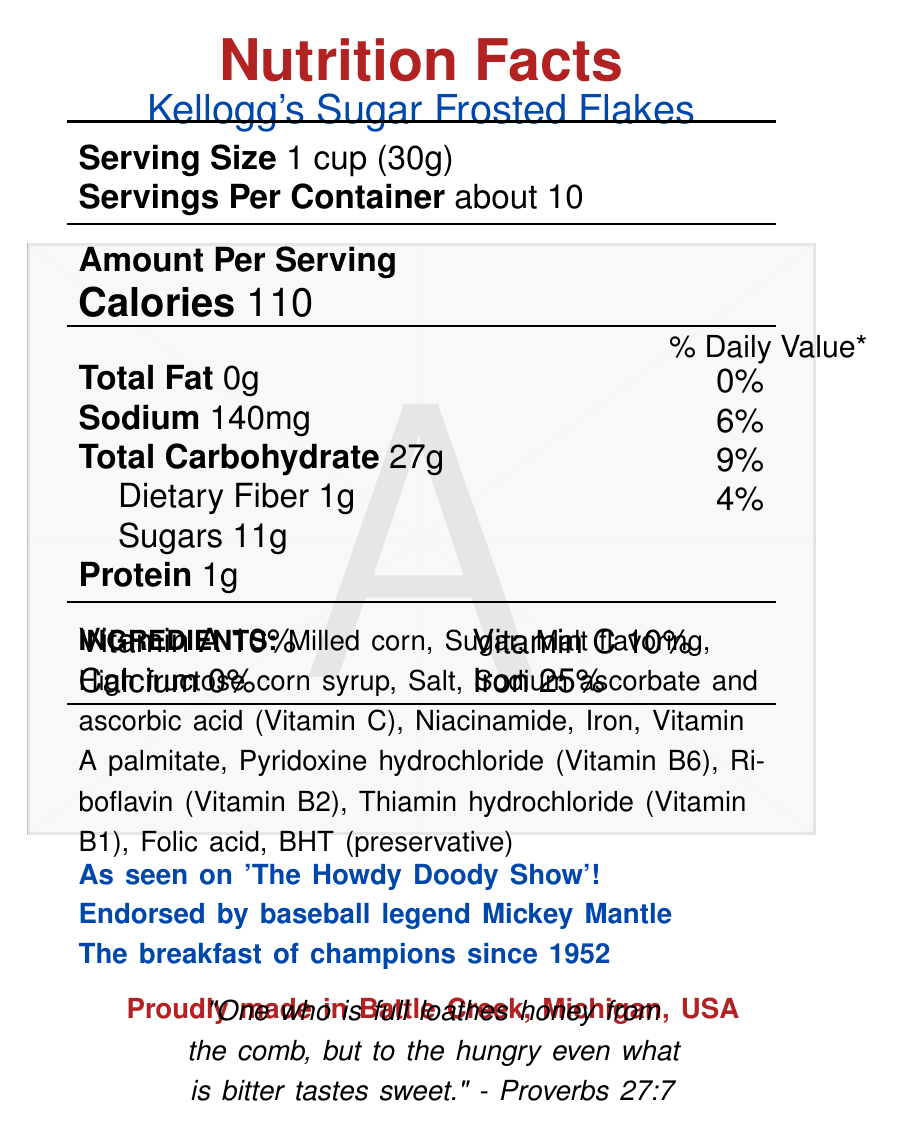What is the serving size for Kellogg's Sugar Frosted Flakes? The serving size is explicitly mentioned as 1 cup (30g) in the document.
Answer: 1 cup (30g) How many servings are there per container of Kellogg's Sugar Frosted Flakes? The document states there are about 10 servings per container.
Answer: About 10 How many calories are there per serving? The document clearly lists the calorie content per serving as 110.
Answer: 110 What is the % Daily Value for sodium in a serving? The % Daily Value for sodium is listed as 6% for a serving size.
Answer: 6% What are the ingredients in Kellogg's Sugar Frosted Flakes? The ingredients are listed in the document under the "INGREDIENTS" section.
Answer: Milled corn, Sugar, Malt flavoring, High fructose corn syrup, Salt, Sodium ascorbate and ascorbic acid (Vitamin C), Niacinamide, Iron, Vitamin A palmitate, Pyridoxine hydrochloride (Vitamin B6), Riboflavin (Vitamin B2), Thiamin hydrochloride (Vitamin B1), Folic acid, BHT (preservative) What vitamins and minerals are found in Kellogg's Sugar Frosted Flakes? A. Vitamin D, Vitamin B12, Zinc B. Vitamin A, Vitamin C, Iron C. Calcium, Magnesium, Potassium The document specifies that the cereal contains Vitamin A (10%), Vitamin C (10%), and Iron (25%).
Answer: B Which of the following statements is true about Kellogg's Sugar Frosted Flakes? A. It contains 2g of protein per serving B. It has 1g of dietary fiber per serving C. It has 5% daily value of total carbohydrates per serving According to the document, it has 1g of dietary fiber per serving.
Answer: B Is this cereal recommended by any famous personalities? The cereal is endorsed by baseball legend Mickey Mantle, as mentioned in the document.
Answer: Yes Is this product made in the USA? The patriotic message states that it is "Proudly made in Battle Creek, Michigan, USA".
Answer: Yes Summarize the nutritional content and special features of Kellogg's Sugar Frosted Flakes. The main idea of the document is to provide nutritional information about Kellogg's Sugar Frosted Flakes, including serving size, calories, and vitamin/mineral content. It also highlights endorsements, nostalgic references, and its American origin.
Answer: Kellogg's Sugar Frosted Flakes is a classic American breakfast cereal with each serving size being 1 cup (30g). There are about 10 servings per container, and each serving has 110 calories. The cereal contains 0g of total fat, 140mg of sodium, 27g of total carbohydrates, 1g of dietary fiber, 11g of sugars, and 1g of protein. It includes vitamins and minerals such as Vitamin A, Vitamin C, and Iron. The ingredients consist of milled corn, sugar, malt flavoring, high fructose corn syrup, and several vitamins and minerals. The cereal has nostalgic and patriotic notes, having been endorsed by Mickey Mantle and featured on 'The Howdy Doody Show'. What was the price of Kellogg's Sugar Frosted Flakes in the 1950s? The document does not provide any information about the price of the cereal.
Answer: Cannot be determined Who is the targeted demographic of Kellogg's Sugar Frosted Flakes? The document mentions "Start your day right with a wholesome family breakfast!", indicating that the cereal is targeted at families.
Answer: Families 